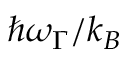<formula> <loc_0><loc_0><loc_500><loc_500>\hbar { \omega } _ { \Gamma } / k _ { B }</formula> 